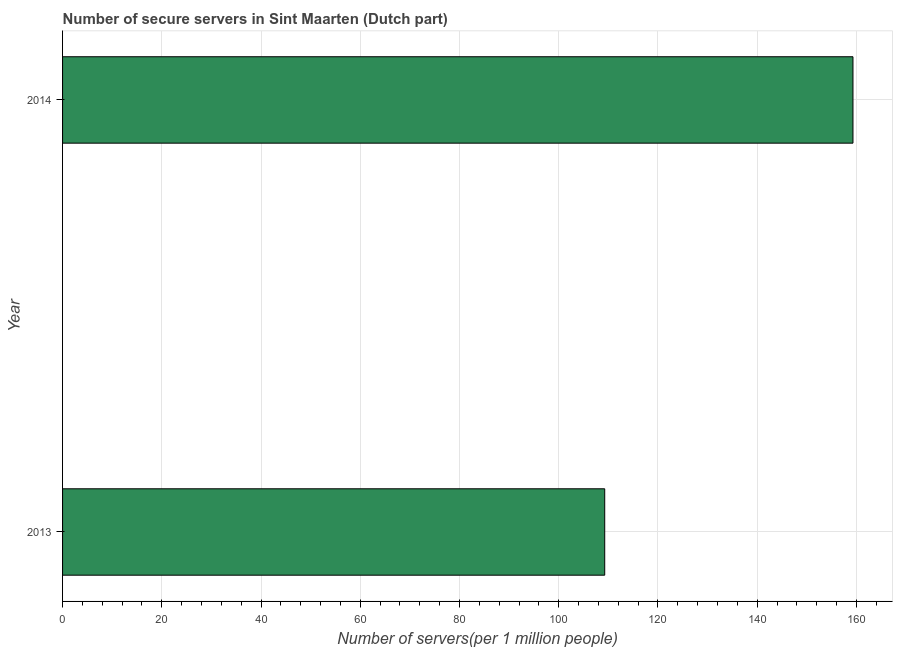Does the graph contain any zero values?
Offer a terse response. No. What is the title of the graph?
Your answer should be very brief. Number of secure servers in Sint Maarten (Dutch part). What is the label or title of the X-axis?
Offer a terse response. Number of servers(per 1 million people). What is the label or title of the Y-axis?
Keep it short and to the point. Year. What is the number of secure internet servers in 2013?
Provide a short and direct response. 109.27. Across all years, what is the maximum number of secure internet servers?
Provide a succinct answer. 159.3. Across all years, what is the minimum number of secure internet servers?
Ensure brevity in your answer.  109.27. What is the sum of the number of secure internet servers?
Provide a short and direct response. 268.57. What is the difference between the number of secure internet servers in 2013 and 2014?
Make the answer very short. -50.03. What is the average number of secure internet servers per year?
Your answer should be very brief. 134.29. What is the median number of secure internet servers?
Offer a terse response. 134.29. In how many years, is the number of secure internet servers greater than 64 ?
Keep it short and to the point. 2. What is the ratio of the number of secure internet servers in 2013 to that in 2014?
Ensure brevity in your answer.  0.69. In how many years, is the number of secure internet servers greater than the average number of secure internet servers taken over all years?
Provide a short and direct response. 1. How many bars are there?
Keep it short and to the point. 2. What is the difference between two consecutive major ticks on the X-axis?
Offer a terse response. 20. What is the Number of servers(per 1 million people) of 2013?
Your answer should be very brief. 109.27. What is the Number of servers(per 1 million people) of 2014?
Ensure brevity in your answer.  159.3. What is the difference between the Number of servers(per 1 million people) in 2013 and 2014?
Provide a succinct answer. -50.03. What is the ratio of the Number of servers(per 1 million people) in 2013 to that in 2014?
Provide a short and direct response. 0.69. 